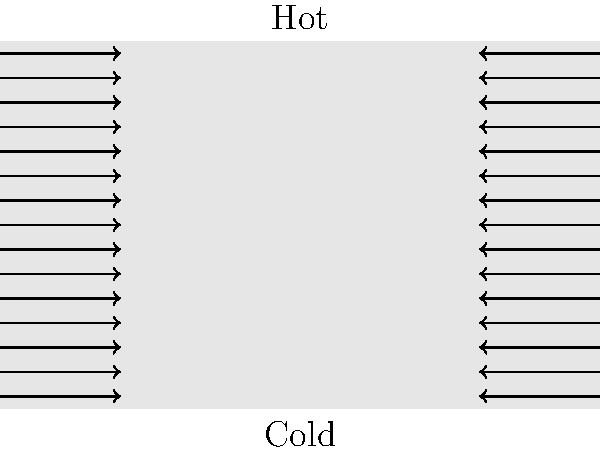Analyze the stress distribution in the stone monument shown above under different weather conditions. How does the temperature gradient affect the internal stress of the monument, and what potential consequences might this have for its structural integrity over time? To analyze the stress distribution in the stone monument under different weather conditions, we need to consider several factors:

1. Thermal expansion: As temperature changes, materials expand or contract. Stone typically expands when heated and contracts when cooled.

2. Temperature gradient: The diagram shows a non-linear temperature gradient from bottom (cold) to top (hot). This uneven heating causes different parts of the monument to expand at different rates.

3. Internal stress: The differential expansion leads to internal stresses within the monument.

4. Stress distribution: The arrows in the diagram represent the stress distribution. The magnitude of stress is greater at the edges due to the constraint of surrounding material.

5. Cyclic loading: Daily and seasonal temperature changes cause repeated expansion and contraction, leading to fatigue over time.

6. Material properties: Stone has low thermal conductivity, which can exacerbate temperature gradients and internal stresses.

7. Potential consequences:
   a) Microcracking: Repeated stress cycles can cause small cracks to form and propagate.
   b) Spalling: Surface layers may detach due to differential expansion.
   c) Weakening: Over time, the accumulation of microdamage can reduce the overall strength of the monument.
   d) Accelerated weathering: Cracks provide pathways for water ingress, leading to faster deterioration.

8. Long-term effects: The cumulative impact of these stresses over many years can significantly affect the monument's structural integrity and appearance.

To mitigate these effects, conservators might consider:
- Using materials with similar thermal expansion coefficients in repairs
- Implementing protective measures against extreme temperature fluctuations
- Regular monitoring and maintenance to address issues early
Answer: Differential thermal expansion causes internal stresses, potentially leading to microcracking, spalling, and long-term structural weakening. 